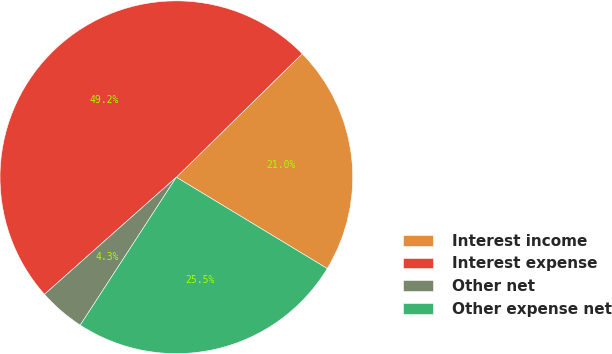Convert chart to OTSL. <chart><loc_0><loc_0><loc_500><loc_500><pie_chart><fcel>Interest income<fcel>Interest expense<fcel>Other net<fcel>Other expense net<nl><fcel>21.01%<fcel>49.21%<fcel>4.27%<fcel>25.51%<nl></chart> 